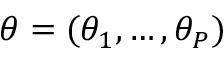<formula> <loc_0><loc_0><loc_500><loc_500>\theta = ( \theta _ { 1 } , \dots , \theta _ { P } )</formula> 